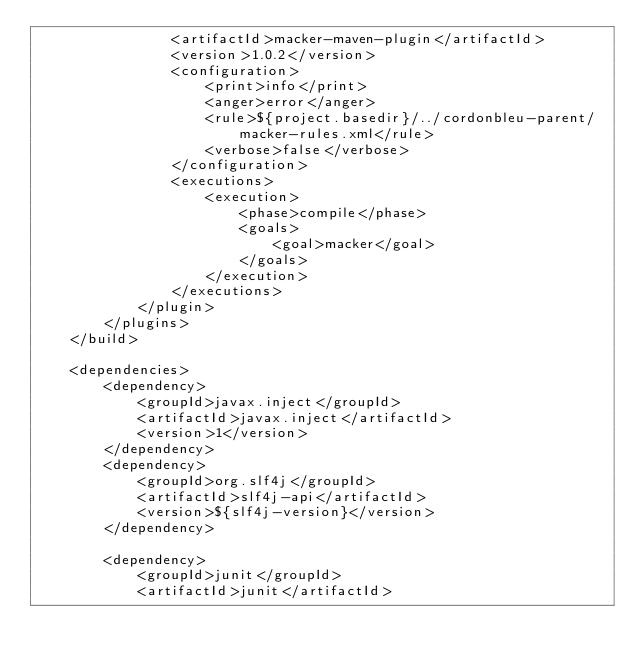Convert code to text. <code><loc_0><loc_0><loc_500><loc_500><_XML_>                <artifactId>macker-maven-plugin</artifactId>
                <version>1.0.2</version>
                <configuration>
                    <print>info</print>
                    <anger>error</anger>
                    <rule>${project.basedir}/../cordonbleu-parent/macker-rules.xml</rule>
                    <verbose>false</verbose>
                </configuration>
                <executions>
                    <execution>
                        <phase>compile</phase>
                        <goals>
                            <goal>macker</goal>
                        </goals>
                    </execution>
                </executions>
            </plugin>
        </plugins>
    </build>

    <dependencies>
        <dependency>
            <groupId>javax.inject</groupId>
            <artifactId>javax.inject</artifactId>
            <version>1</version>
        </dependency>
        <dependency>
            <groupId>org.slf4j</groupId>
            <artifactId>slf4j-api</artifactId>
            <version>${slf4j-version}</version>
        </dependency>

        <dependency>
            <groupId>junit</groupId>
            <artifactId>junit</artifactId></code> 